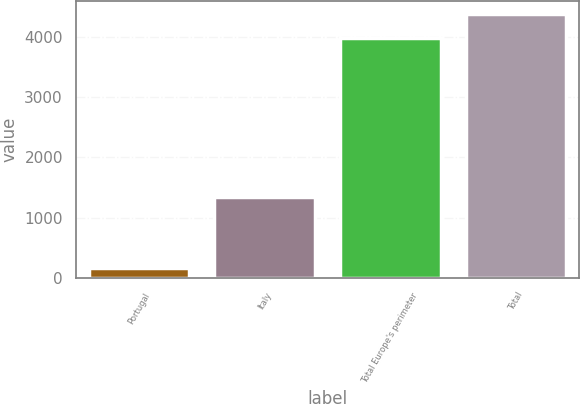<chart> <loc_0><loc_0><loc_500><loc_500><bar_chart><fcel>Portugal<fcel>Italy<fcel>Total Europe's perimeter<fcel>Total<nl><fcel>162<fcel>1336<fcel>3981<fcel>4374.3<nl></chart> 